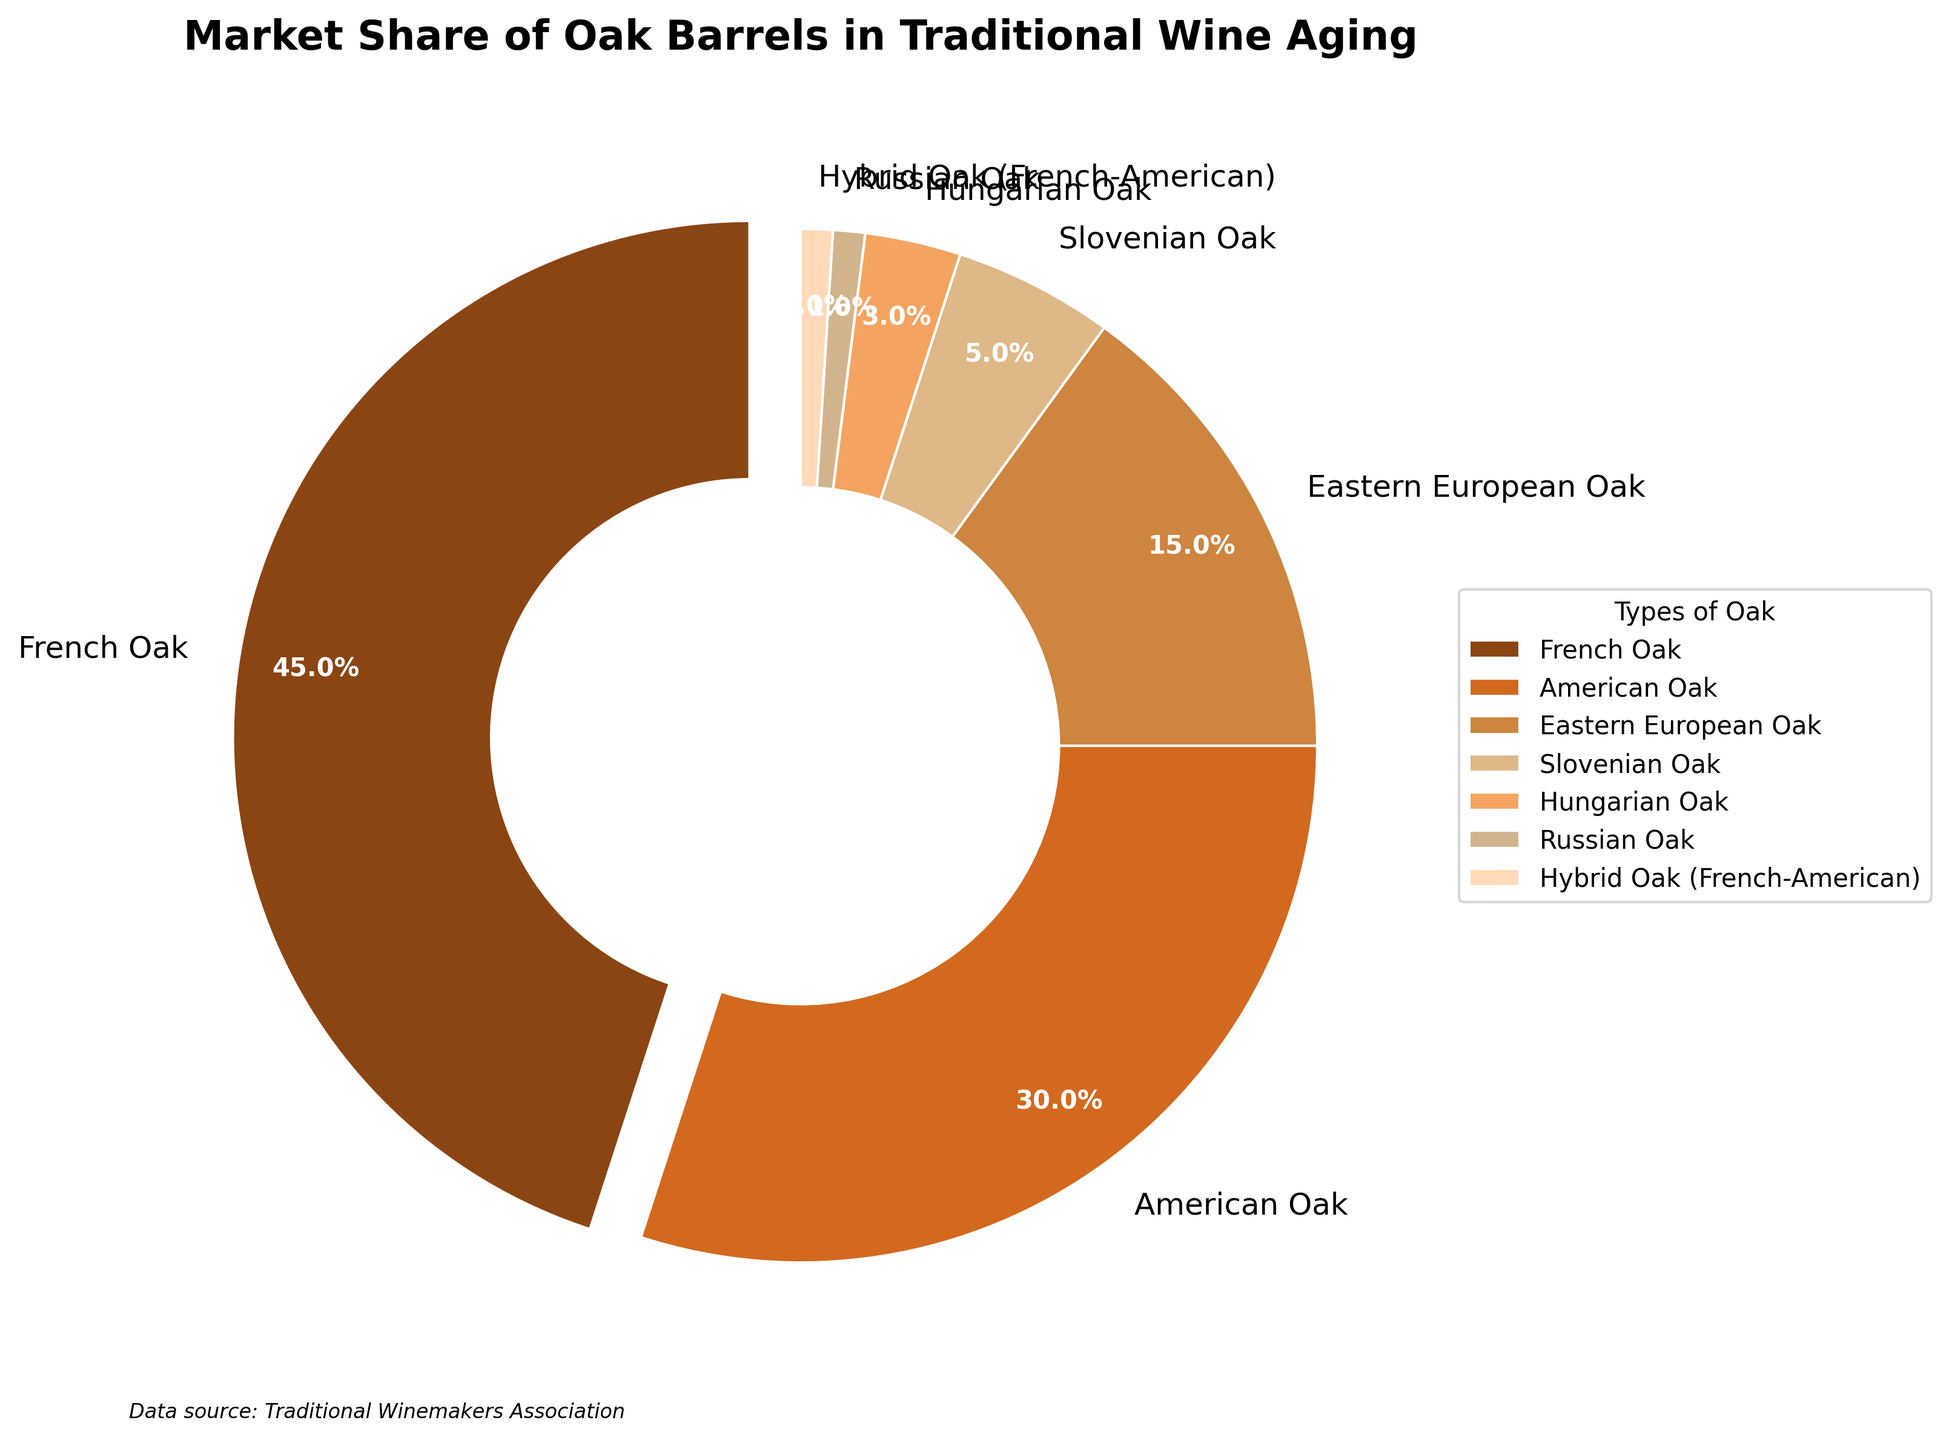What's the market share of American Oak barrels? American Oak barrels have a market share represented as 30% in the pie chart. It is directly indicated in the visual with a label "American Oak" associated with the percentage "30%"
Answer: 30% Which type of oak barrel has the smallest market share? The segment labeled "Russian Oak" shows 1%, which is the smallest percentage of all the segments shown in the pie chart.
Answer: Russian Oak How much greater is the market share of French Oak compared to Eastern European Oak? The market share of French Oak is 45%, and Eastern European Oak is 15%. The difference is 45% - 15% = 30%
Answer: 30% What is the total market share of all barrels other than French Oak? The total market share is 100%. Subtract French Oak's share: 100% - 45% = 55%. Summing up the shares of American Oak, Eastern European Oak, Slovenian Oak, Hungarian Oak, Russian Oak, and Hybrid Oak (30% + 15% + 5% + 3% + 1% + 1%), it also sums up to 55%
Answer: 55% Which color represents the French Oak in the pie chart? The French Oak segment is highlighted with slightly exploded out and is represented as the first wedge on the pie chart, and is colored in a dark brown shade.
Answer: Dark brown shade In terms of market share, arrange American Oak, Eastern European Oak, and Slovenian Oak in ascending order. Based on the visual, their shares are 30% for American Oak, 15% for Eastern European Oak, and 5% for Slovenian Oak. Arranged in ascending order: Slovenian Oak (5%), Eastern European Oak (15%), American Oak (30%)
Answer: Slovenian Oak, Eastern European Oak, American Oak What percentage of the market do the combined shares of Slovenian Oak and Hybrid Oak represent? Slovenian Oak has 5% and Hybrid Oak has 1%. Adding them gives 5% + 1% = 6%
Answer: 6% Which oak barrels collectively hold more market share: Hungarian Oak and Russian Oak combined or Eastern European Oak? Hungarian Oak and Russian Oak combined share is 3% + 1% = 4%. Eastern European Oak has a market share of 15%. Therefore, Eastern European Oak has a greater share than the combined share of Hungarian and Russian Oak.
Answer: Eastern European Oak 